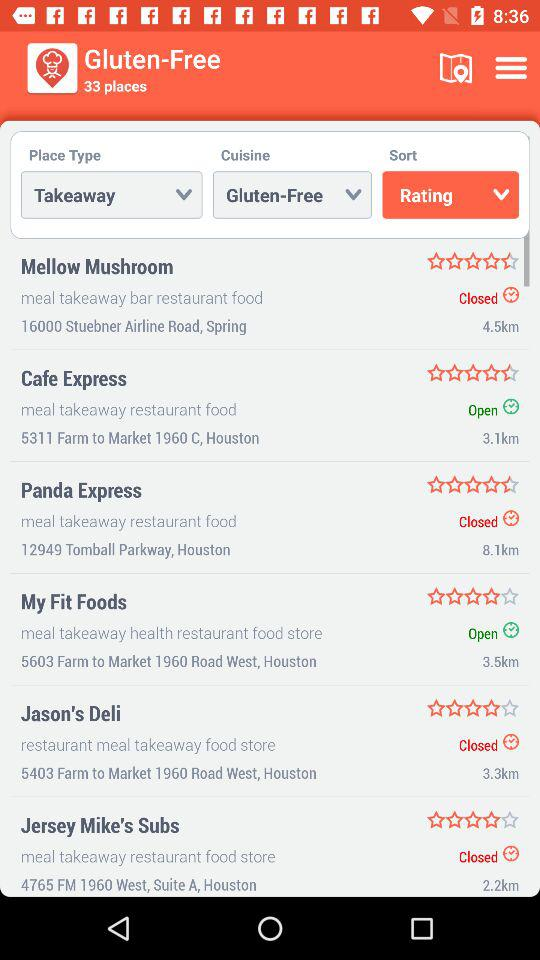How many places are there in total?
Answer the question using a single word or phrase. 33 